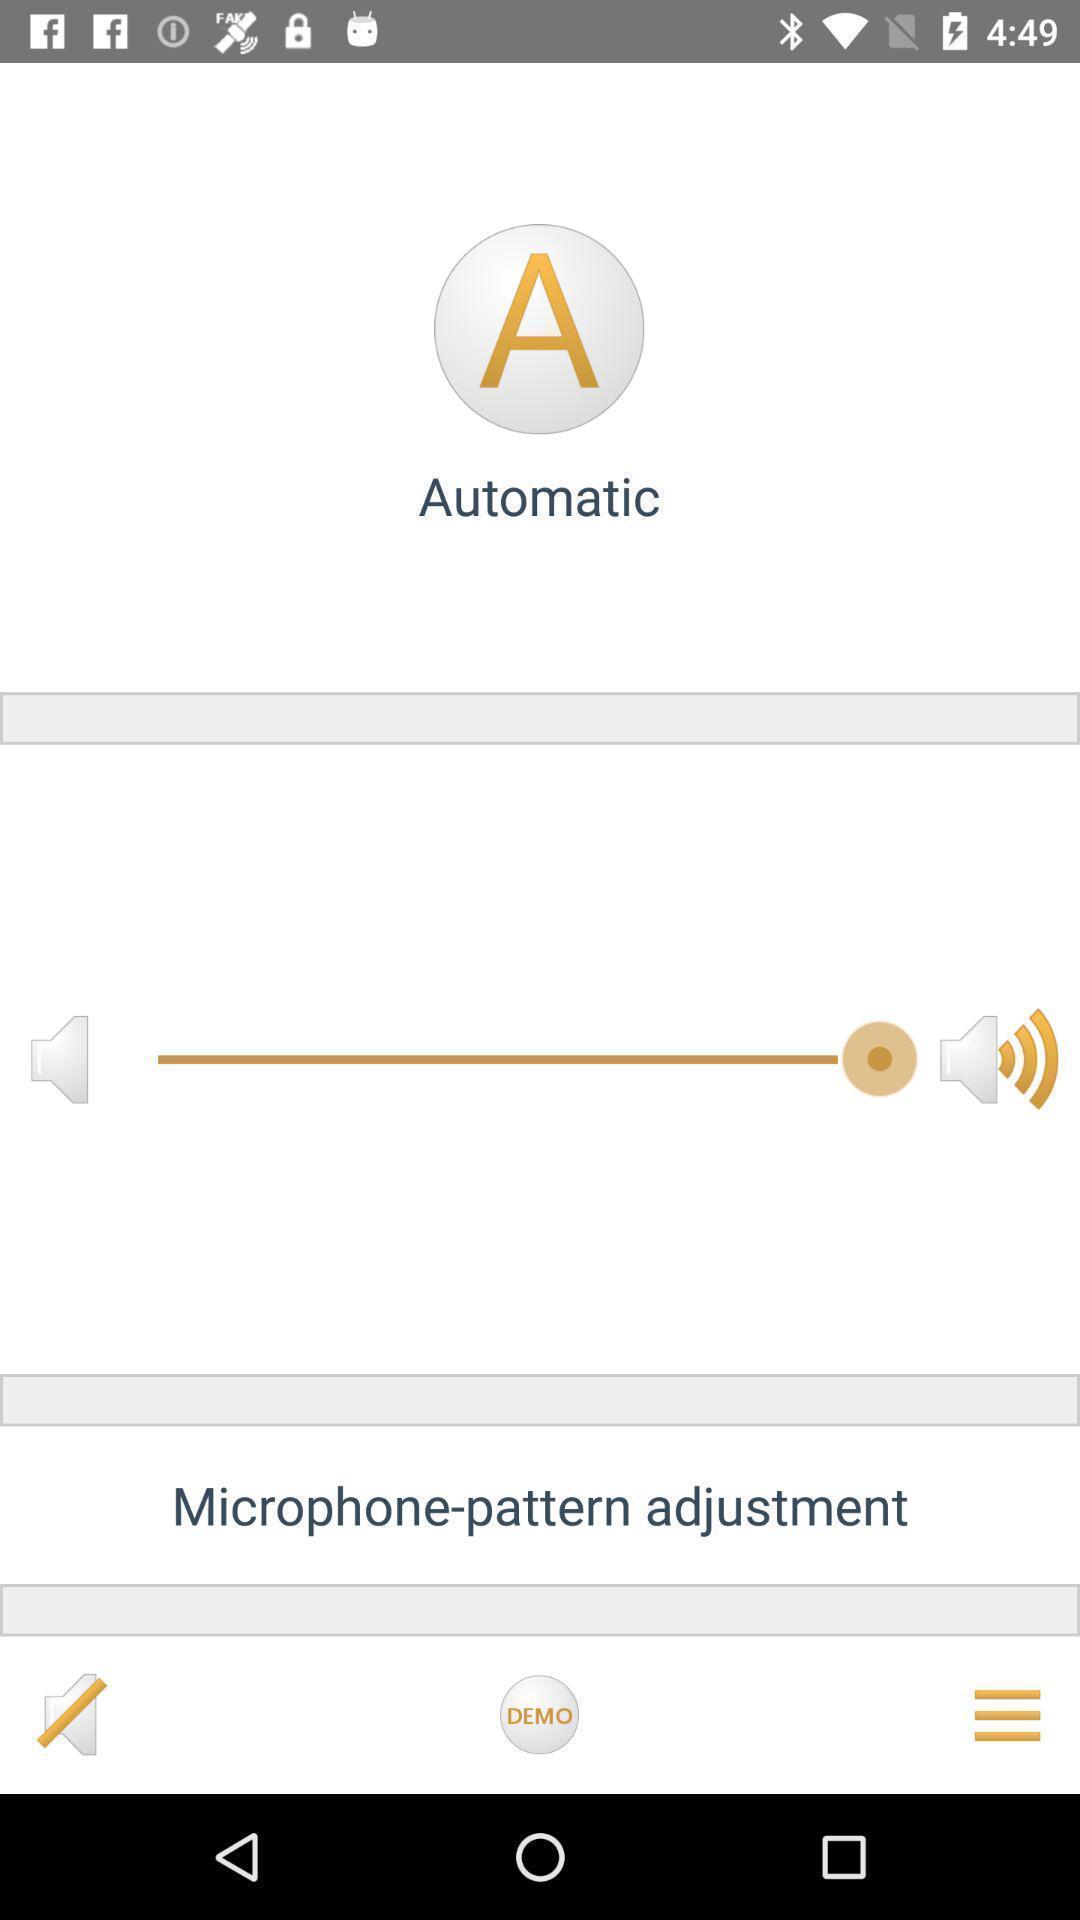Explain the elements present in this screenshot. Settings page of audio controlling for devices. 